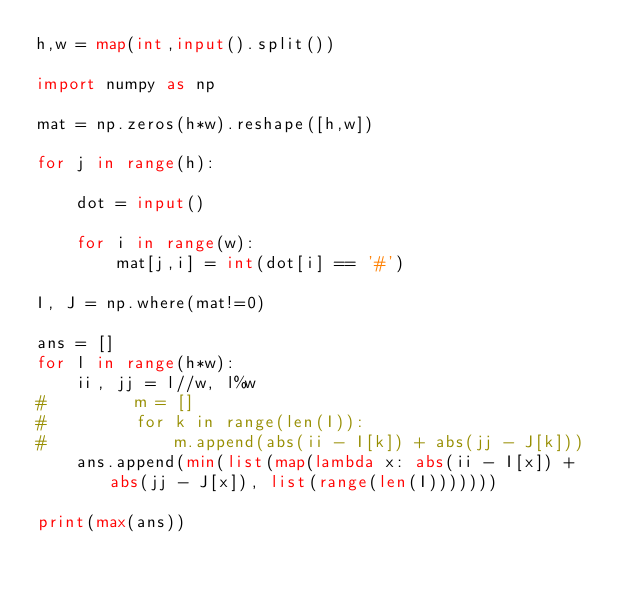Convert code to text. <code><loc_0><loc_0><loc_500><loc_500><_Python_>h,w = map(int,input().split())

import numpy as np

mat = np.zeros(h*w).reshape([h,w])

for j in range(h):
    
    dot = input()
    
    for i in range(w):
        mat[j,i] = int(dot[i] == '#')

I, J = np.where(mat!=0)

ans = []
for l in range(h*w):
    ii, jj = l//w, l%w
#         m = []
#         for k in range(len(I)):
#             m.append(abs(ii - I[k]) + abs(jj - J[k]))
    ans.append(min(list(map(lambda x: abs(ii - I[x]) + abs(jj - J[x]), list(range(len(I)))))))

print(max(ans))</code> 